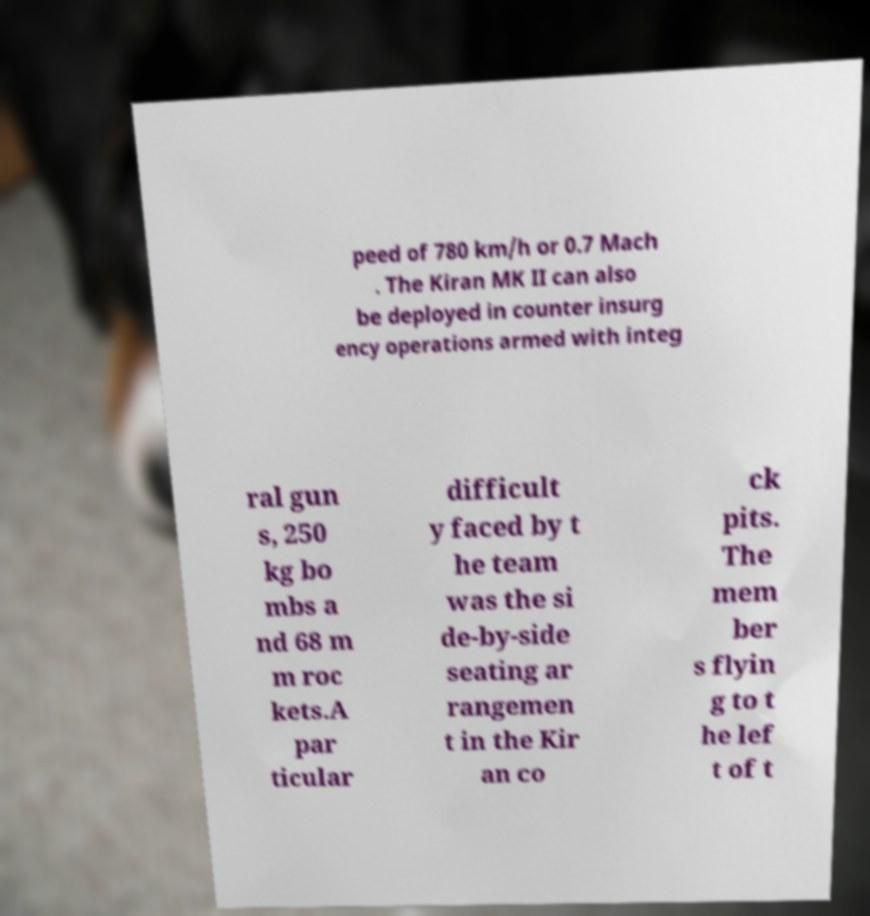Could you extract and type out the text from this image? peed of 780 km/h or 0.7 Mach . The Kiran MK II can also be deployed in counter insurg ency operations armed with integ ral gun s, 250 kg bo mbs a nd 68 m m roc kets.A par ticular difficult y faced by t he team was the si de-by-side seating ar rangemen t in the Kir an co ck pits. The mem ber s flyin g to t he lef t of t 